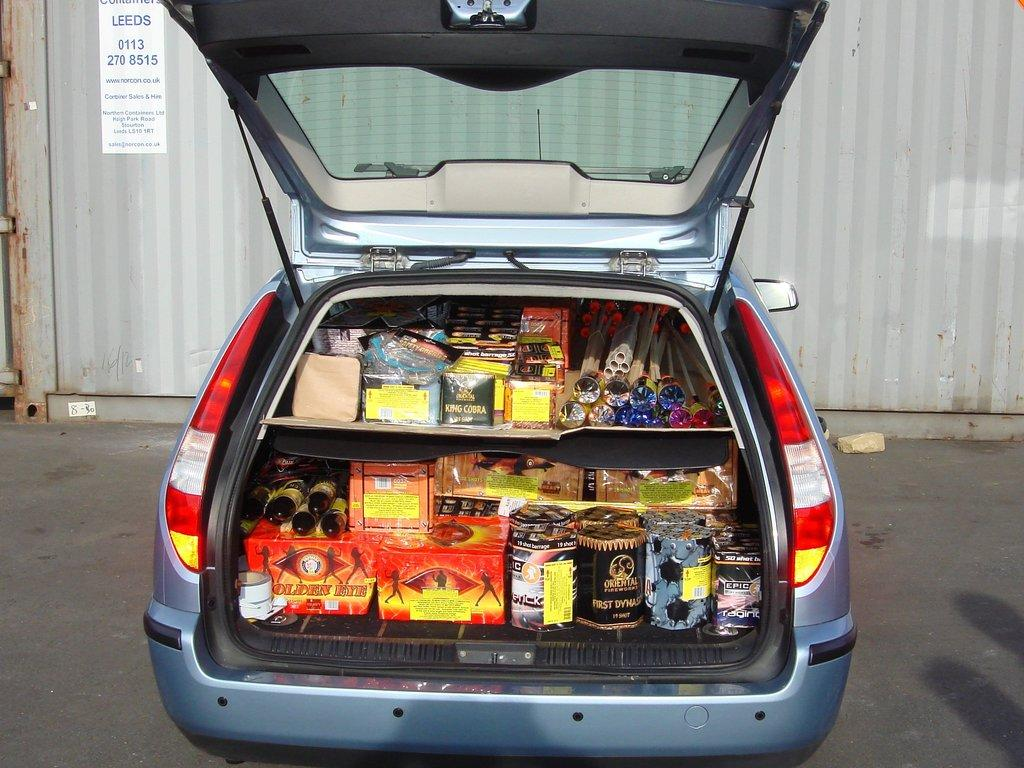What is located inside the car boot in the image? There is stock inside the car boot in the image. Where is the stock positioned in the image? The stock is in the center of the image. What is the other main subject in the image? There is a poster on a dock in the image. Where is the poster located in the image? The poster is in the center of the image. What type of grass can be seen growing on the poster in the image? There is no grass visible on the poster in the image. How does the fog affect the visibility of the stock in the car boot? There is no fog present in the image, so it does not affect the visibility of the stock. 